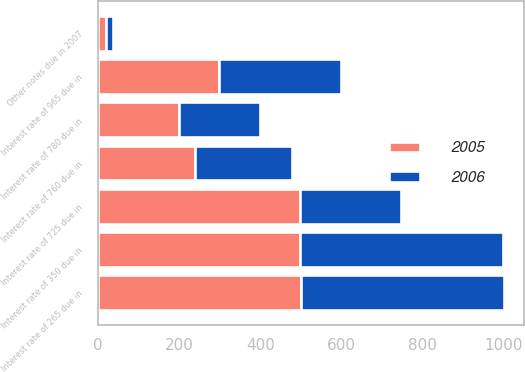Convert chart. <chart><loc_0><loc_0><loc_500><loc_500><stacked_bar_chart><ecel><fcel>Interest rate of 780 due in<fcel>Interest rate of 265 due in<fcel>Interest rate of 350 due in<fcel>Interest rate of 725 due in<fcel>Interest rate of 965 due in<fcel>Interest rate of 760 due in<fcel>Other notes due in 2007<nl><fcel>2006<fcel>200<fcel>500<fcel>500<fcel>249<fcel>300<fcel>239<fcel>18<nl><fcel>2005<fcel>200<fcel>500<fcel>499<fcel>499<fcel>299<fcel>239<fcel>19<nl></chart> 